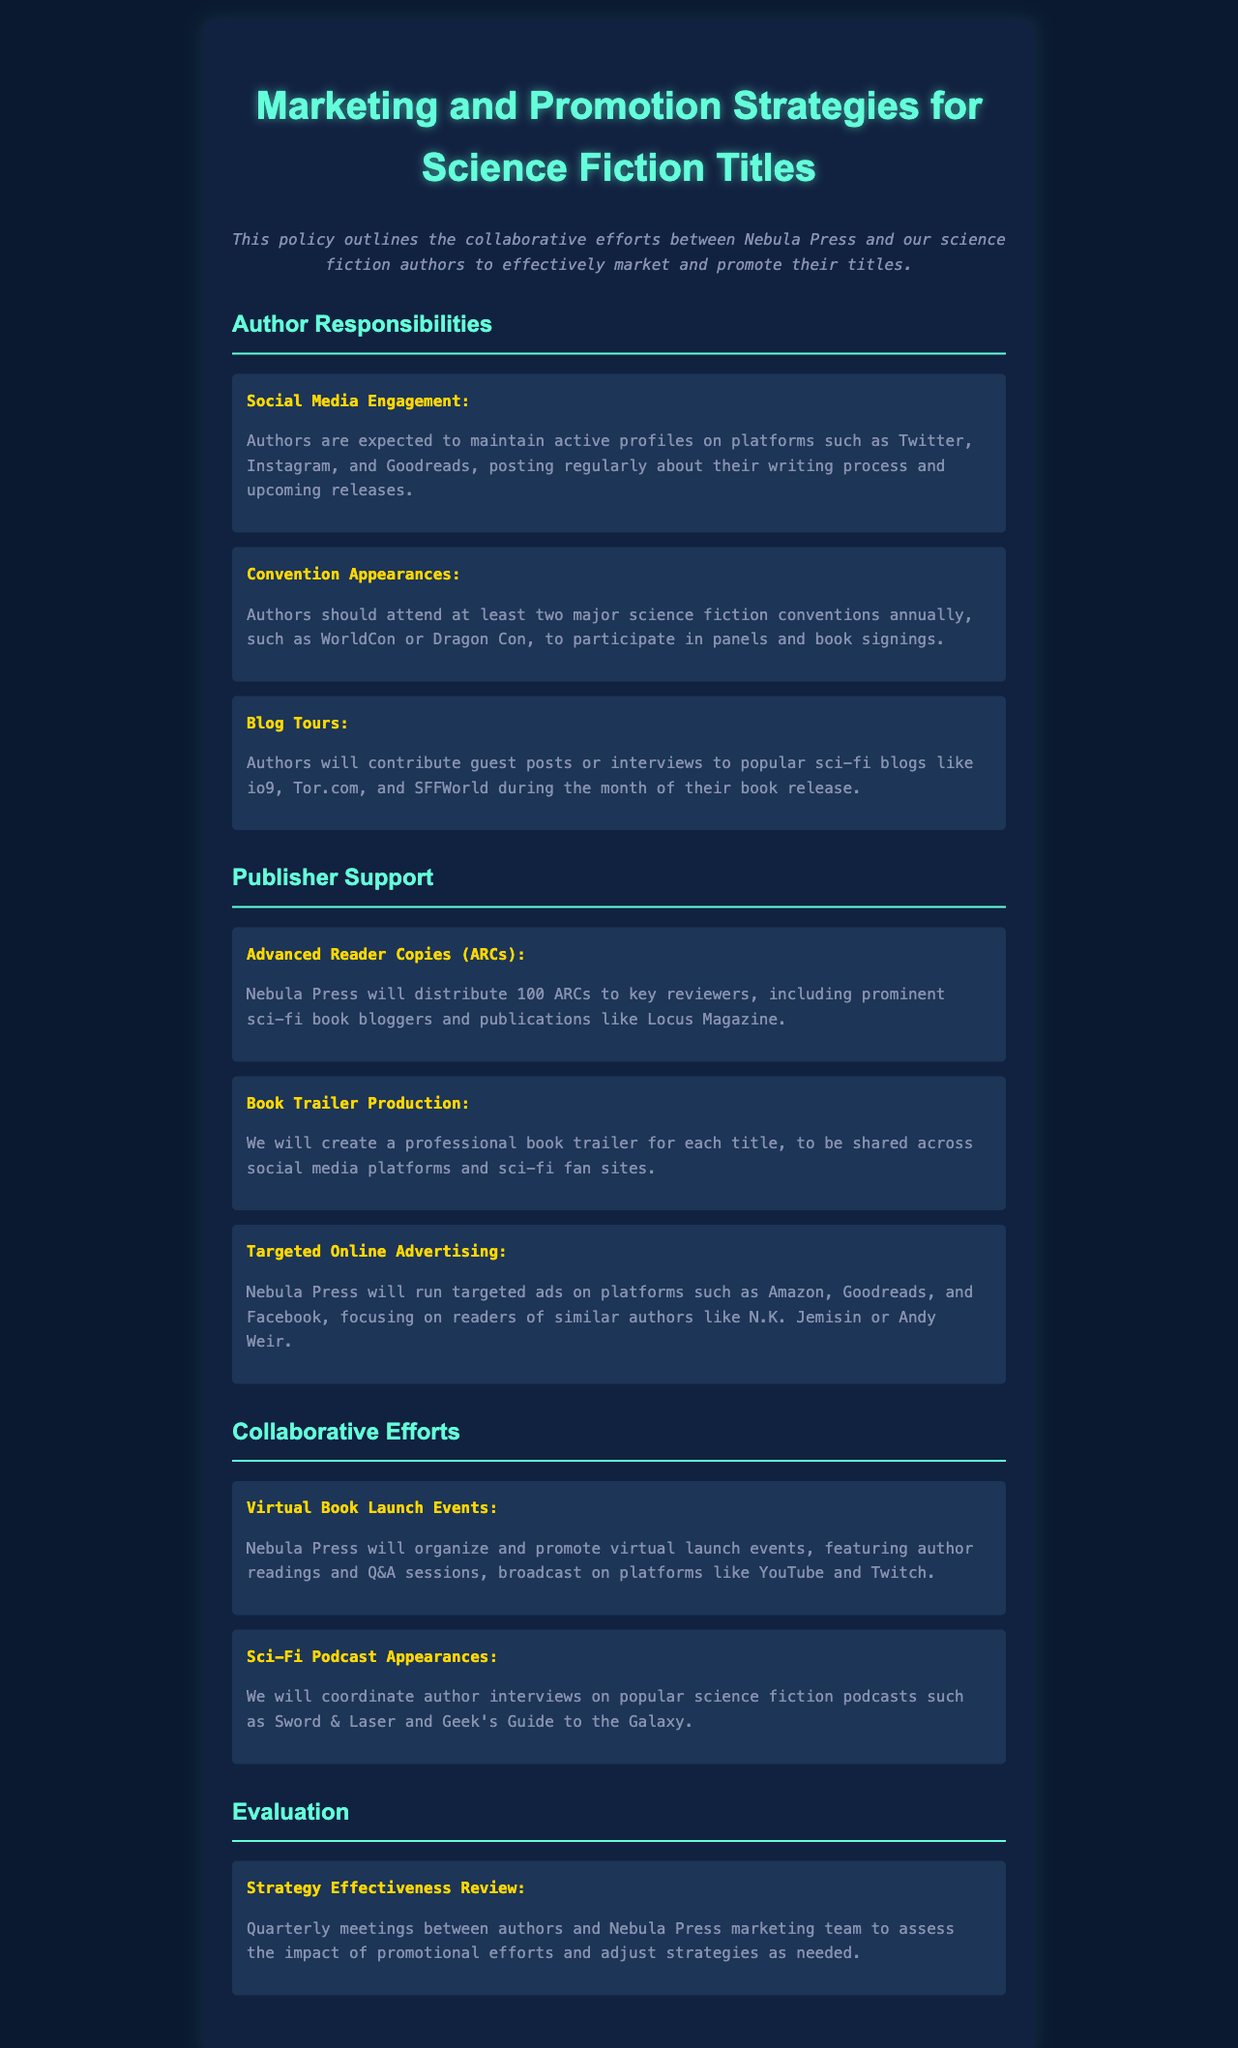What is the expected number of major conventions authors should attend annually? The document states that authors should attend at least two major science fiction conventions annually.
Answer: two What type of social media platforms should authors engage on? Authors are expected to maintain active profiles on platforms such as Twitter, Instagram, and Goodreads.
Answer: Twitter, Instagram, Goodreads How many Advanced Reader Copies will be distributed by Nebula Press? The document specifies that Nebula Press will distribute 100 ARCs to key reviewers.
Answer: 100 What is a supportive service provided by the publisher to promote each title? Nebula Press will create a professional book trailer for each title.
Answer: book trailer What is the focus of the targeted online advertising? The document mentions that targeted ads will focus on readers of similar authors like N.K. Jemisin or Andy Weir.
Answer: N.K. Jemisin or Andy Weir What type of joint events will Nebula Press organize? The document outlines that Nebula Press will organize and promote virtual launch events.
Answer: virtual launch events How often will the strategy effectiveness review meetings occur? The document indicates that strategy effectiveness review meetings will occur quarterly.
Answer: quarterly What type of appearances will authors make on podcasts? The document states that authors will be interviewed on popular science fiction podcasts.
Answer: interviews Who are some popular sci-fi blogs authors will contribute to during their book release? The document lists popular sci-fi blogs like io9, Tor.com, and SFFWorld for contributions.
Answer: io9, Tor.com, SFFWorld 